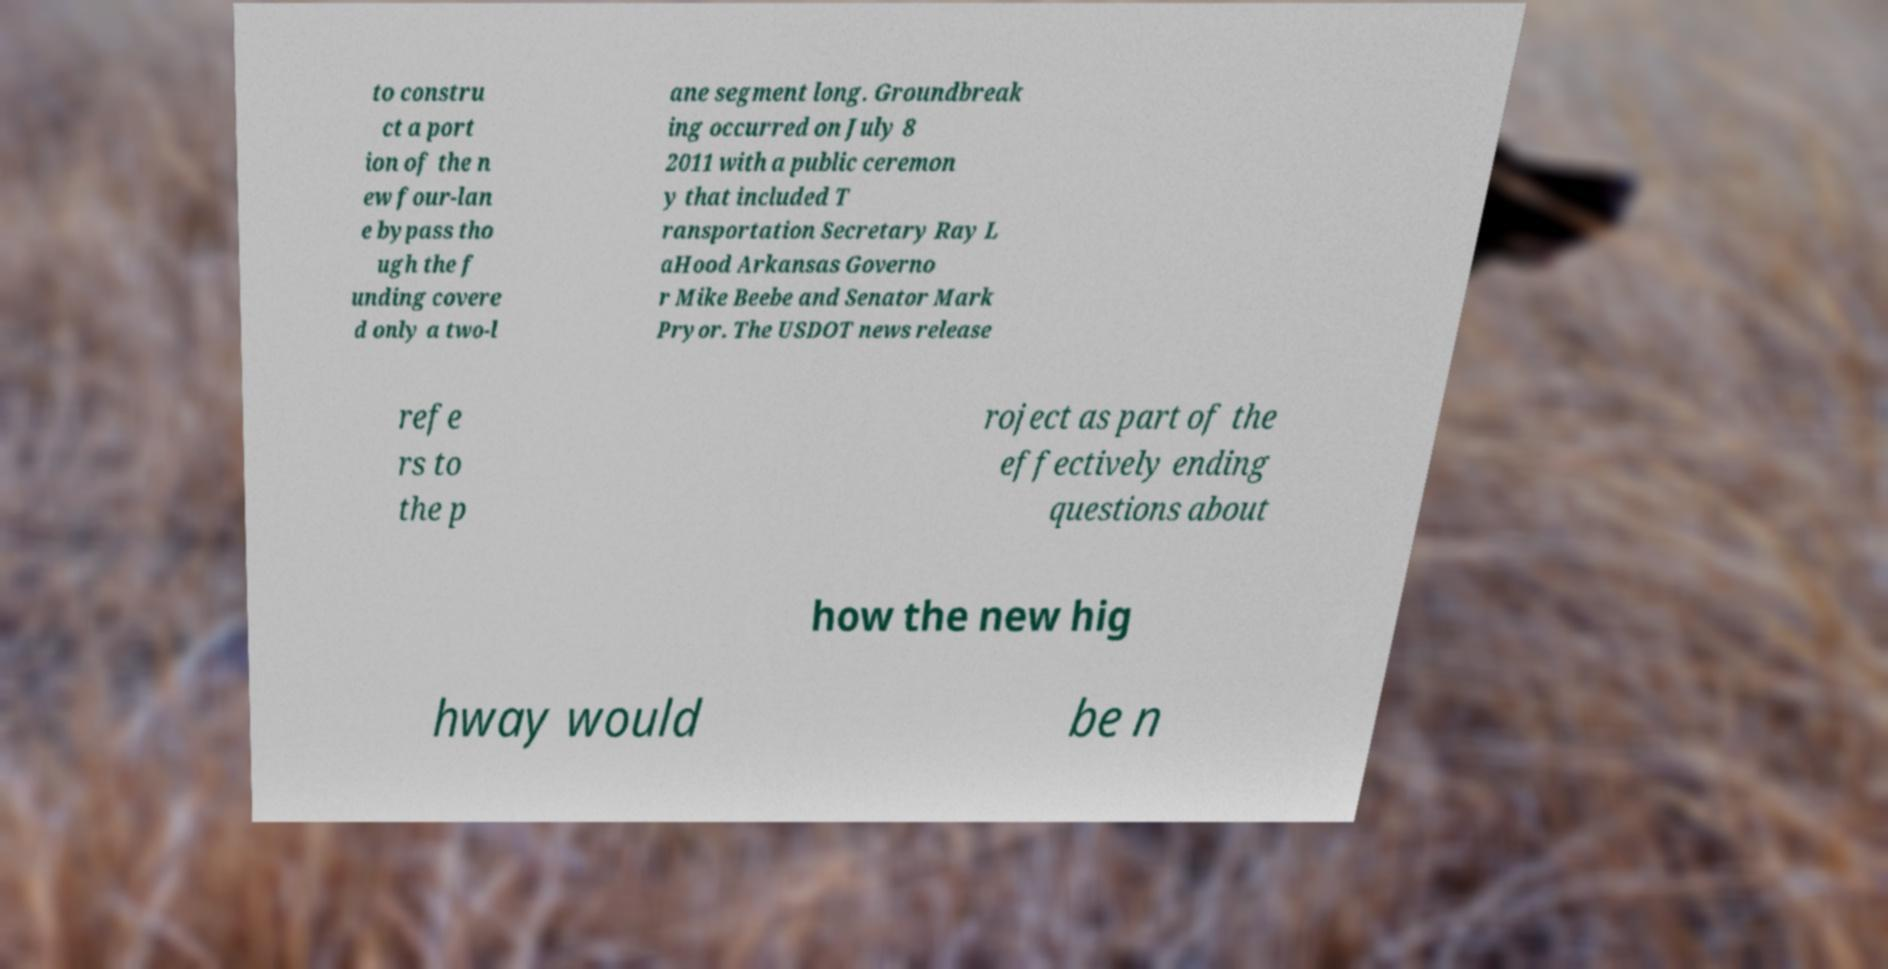Please identify and transcribe the text found in this image. to constru ct a port ion of the n ew four-lan e bypass tho ugh the f unding covere d only a two-l ane segment long. Groundbreak ing occurred on July 8 2011 with a public ceremon y that included T ransportation Secretary Ray L aHood Arkansas Governo r Mike Beebe and Senator Mark Pryor. The USDOT news release refe rs to the p roject as part of the effectively ending questions about how the new hig hway would be n 